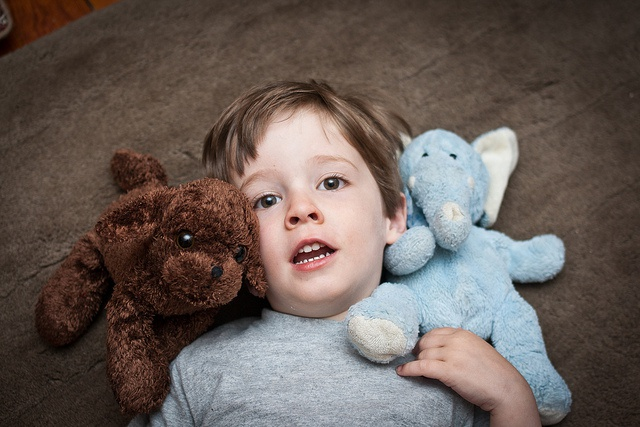Describe the objects in this image and their specific colors. I can see people in black, darkgray, tan, gray, and lightgray tones, teddy bear in black, maroon, and brown tones, and dog in black, maroon, and brown tones in this image. 